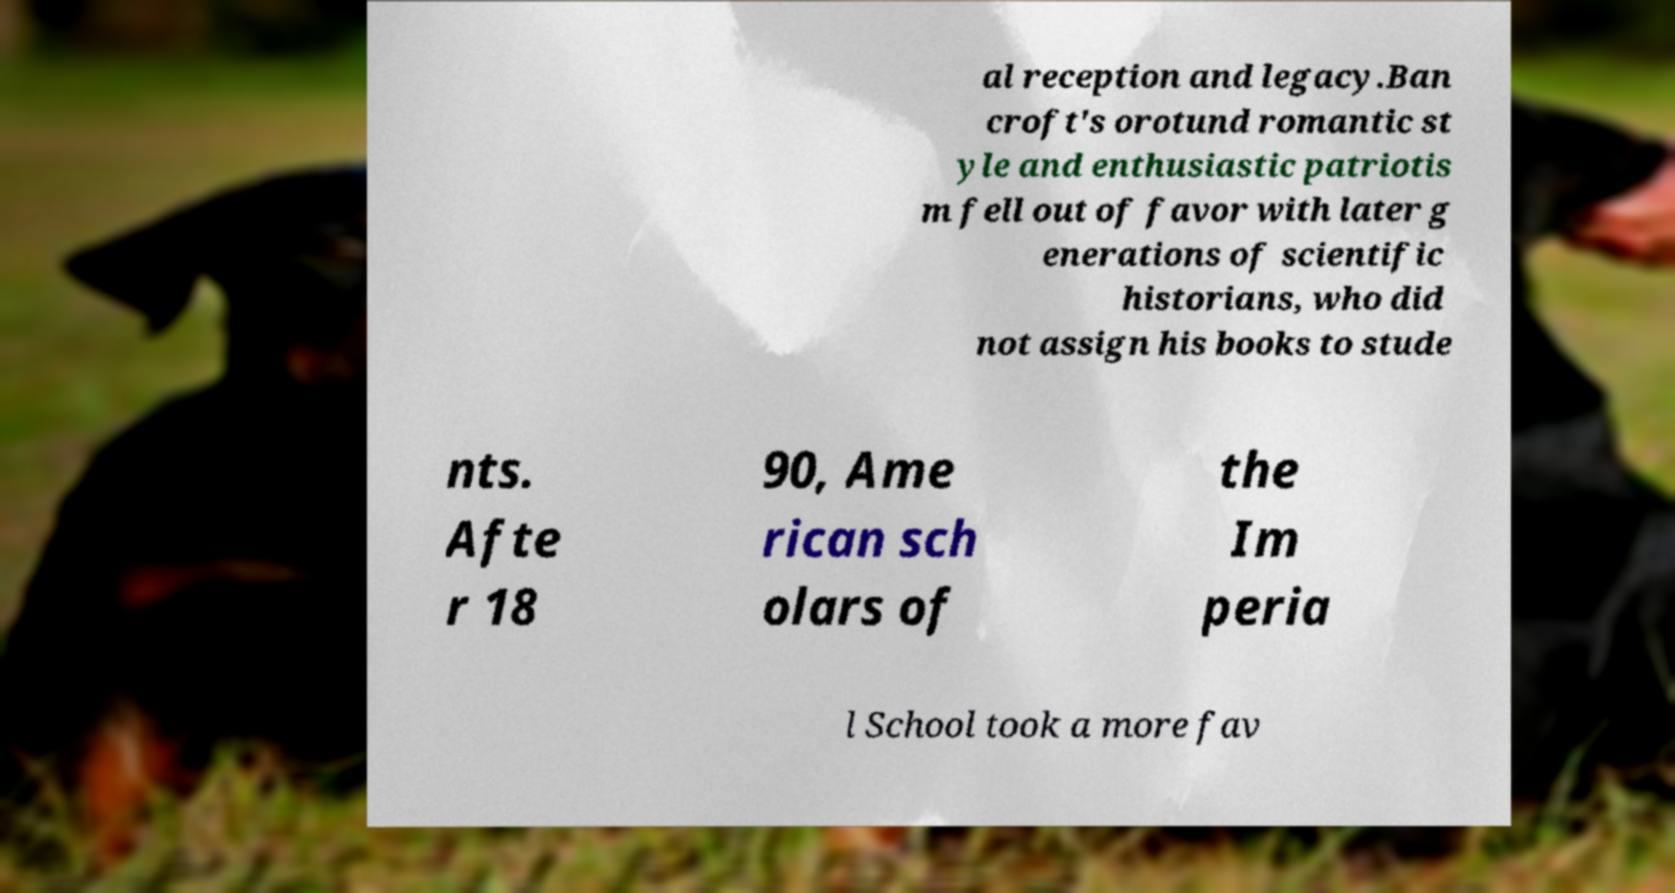Can you read and provide the text displayed in the image?This photo seems to have some interesting text. Can you extract and type it out for me? al reception and legacy.Ban croft's orotund romantic st yle and enthusiastic patriotis m fell out of favor with later g enerations of scientific historians, who did not assign his books to stude nts. Afte r 18 90, Ame rican sch olars of the Im peria l School took a more fav 